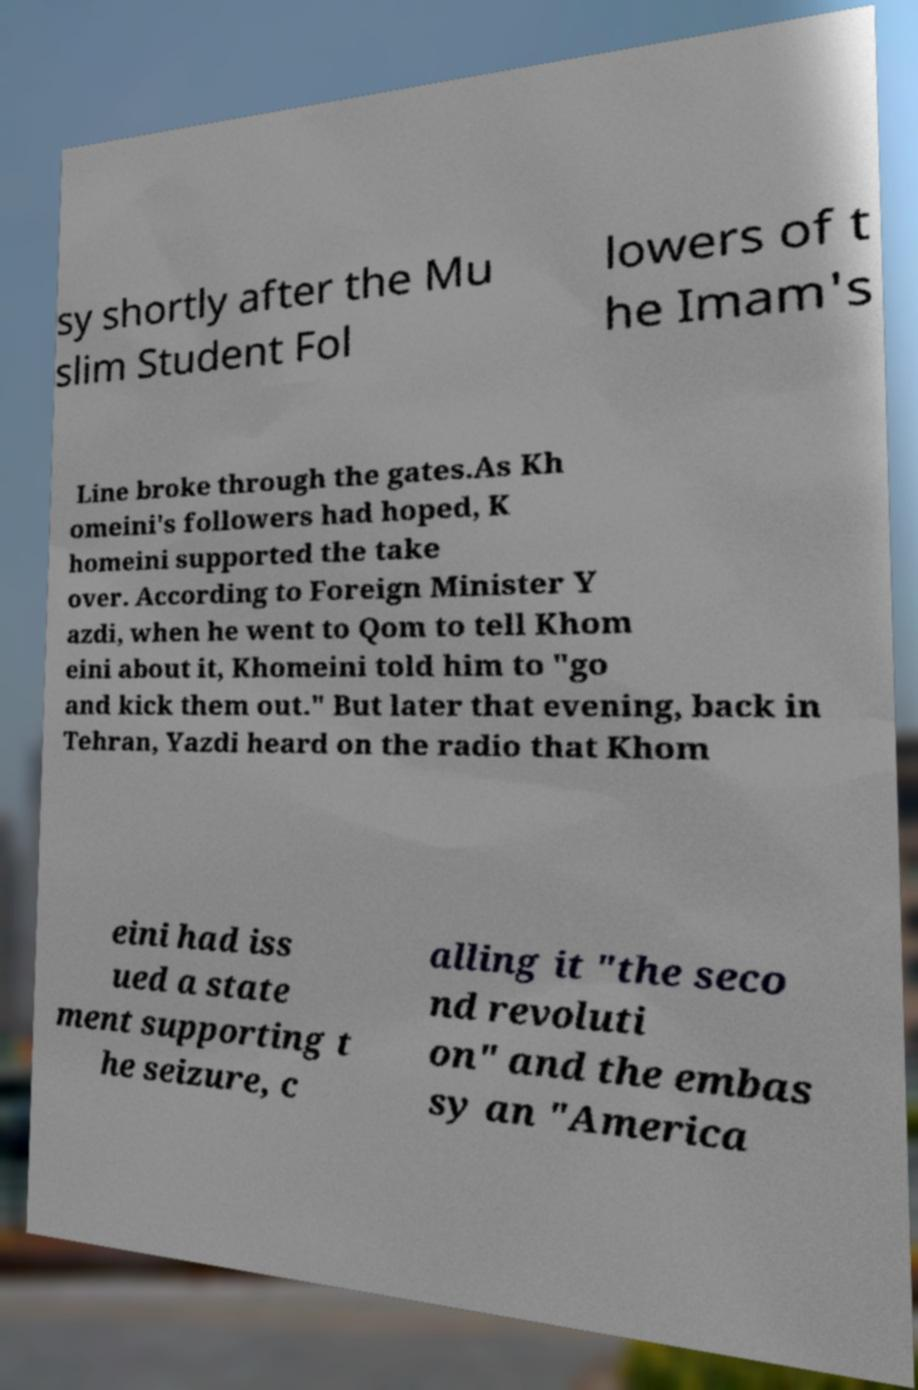Could you assist in decoding the text presented in this image and type it out clearly? sy shortly after the Mu slim Student Fol lowers of t he Imam's Line broke through the gates.As Kh omeini's followers had hoped, K homeini supported the take over. According to Foreign Minister Y azdi, when he went to Qom to tell Khom eini about it, Khomeini told him to "go and kick them out." But later that evening, back in Tehran, Yazdi heard on the radio that Khom eini had iss ued a state ment supporting t he seizure, c alling it "the seco nd revoluti on" and the embas sy an "America 